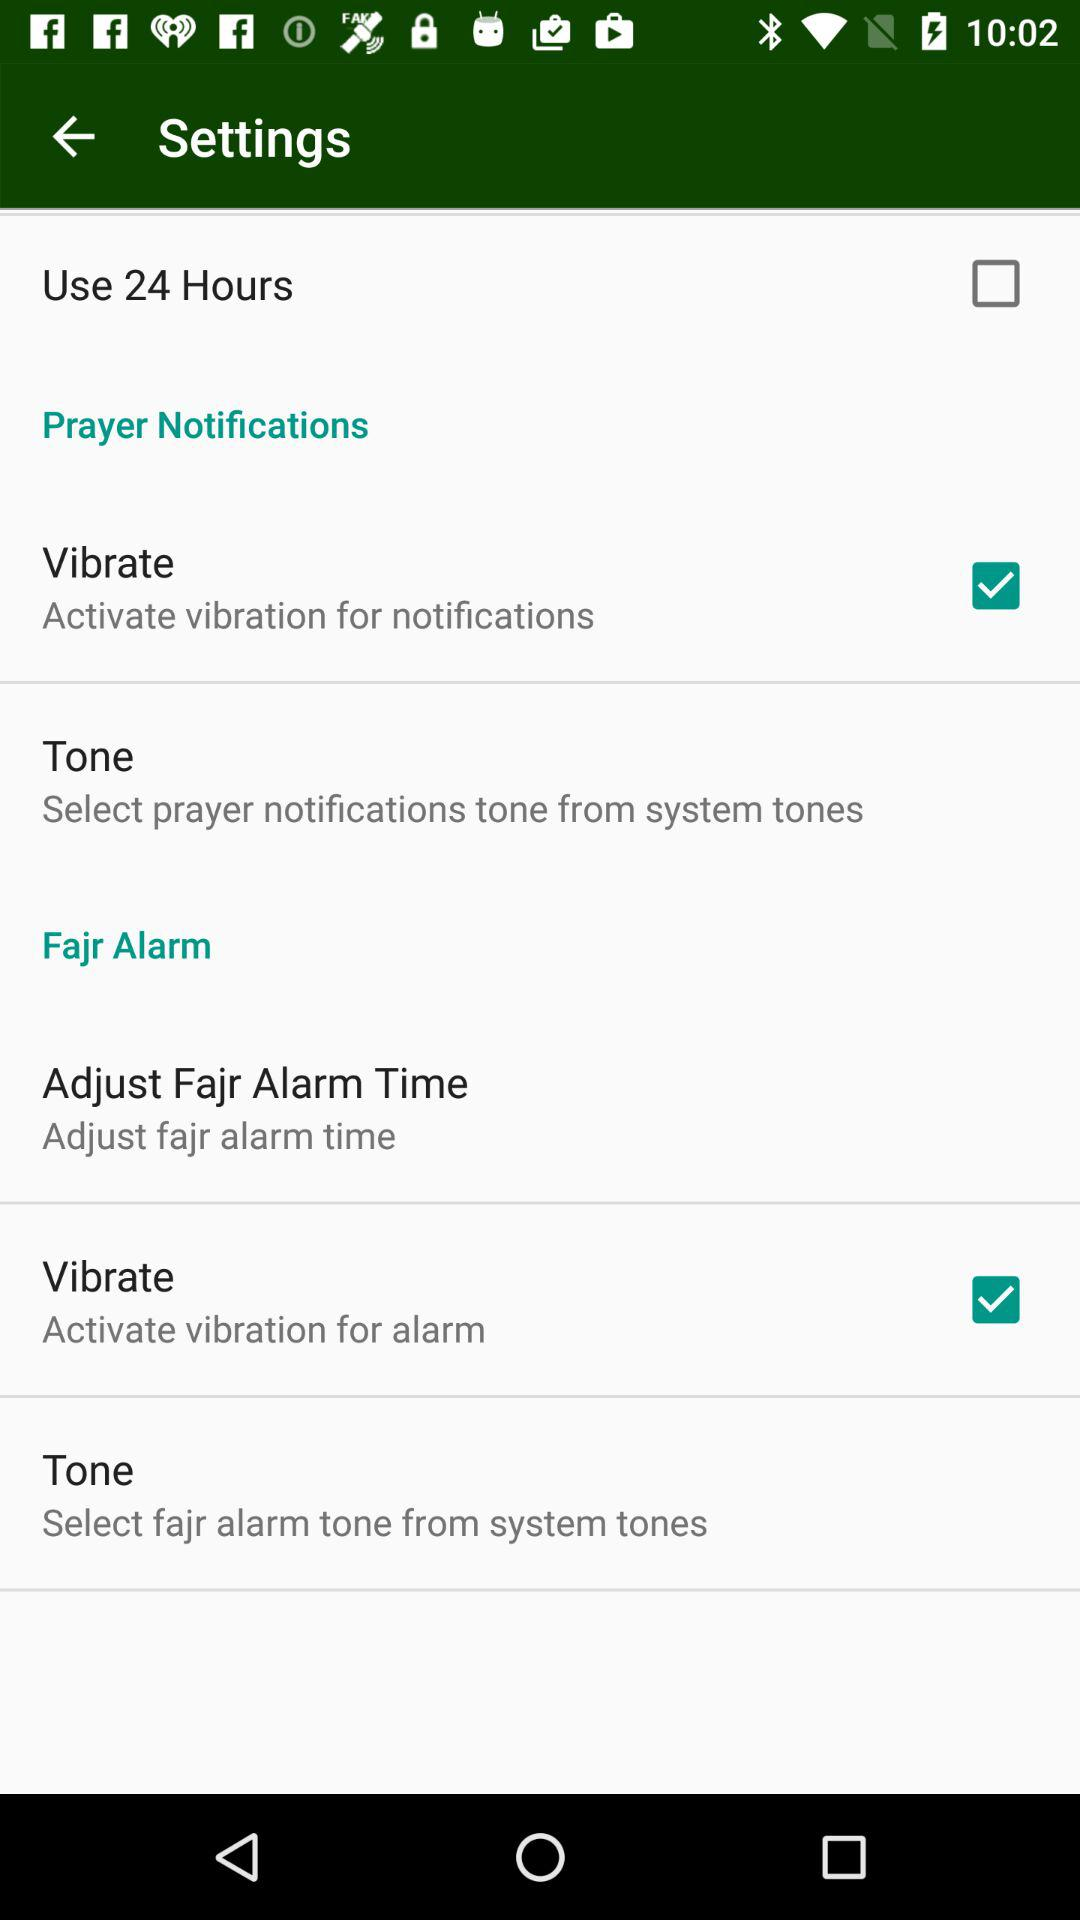What is the status of the "Vibrate" in "Fajr Alarm"? The status is "on". 